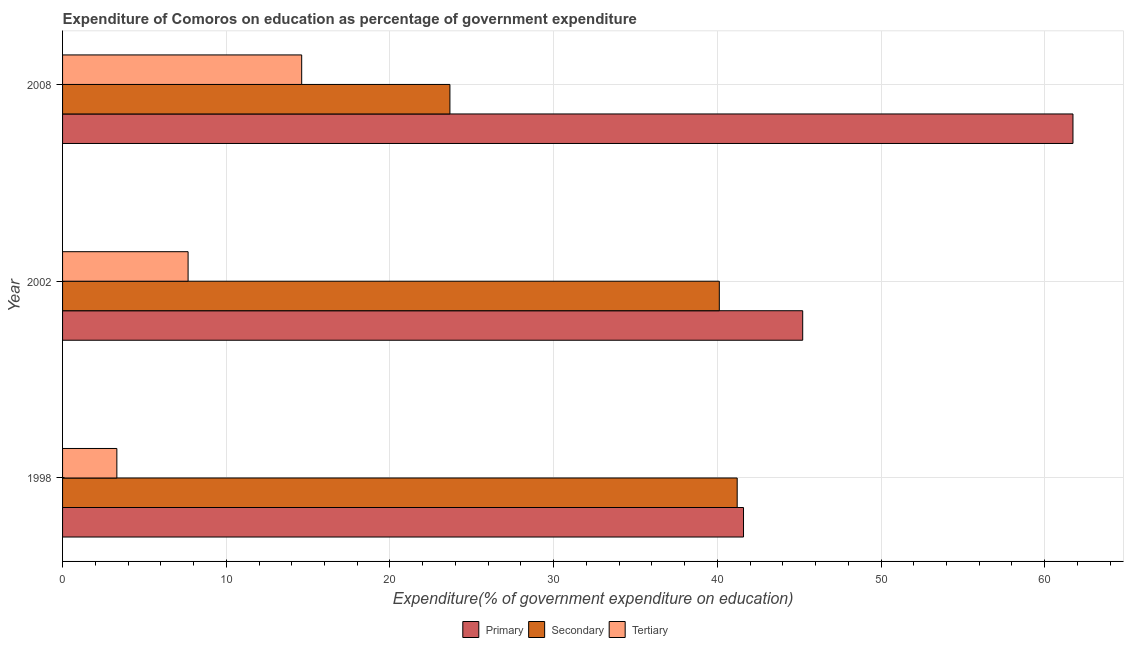Are the number of bars on each tick of the Y-axis equal?
Keep it short and to the point. Yes. How many bars are there on the 1st tick from the top?
Your answer should be compact. 3. What is the label of the 1st group of bars from the top?
Give a very brief answer. 2008. In how many cases, is the number of bars for a given year not equal to the number of legend labels?
Ensure brevity in your answer.  0. What is the expenditure on tertiary education in 2008?
Provide a short and direct response. 14.61. Across all years, what is the maximum expenditure on secondary education?
Provide a short and direct response. 41.21. Across all years, what is the minimum expenditure on tertiary education?
Your response must be concise. 3.32. What is the total expenditure on primary education in the graph?
Your answer should be very brief. 148.54. What is the difference between the expenditure on tertiary education in 2002 and that in 2008?
Offer a terse response. -6.94. What is the difference between the expenditure on tertiary education in 2008 and the expenditure on secondary education in 2002?
Keep it short and to the point. -25.51. What is the average expenditure on primary education per year?
Your response must be concise. 49.51. In the year 1998, what is the difference between the expenditure on secondary education and expenditure on tertiary education?
Give a very brief answer. 37.9. In how many years, is the expenditure on primary education greater than 8 %?
Offer a very short reply. 3. What is the ratio of the expenditure on secondary education in 1998 to that in 2002?
Make the answer very short. 1.03. What is the difference between the highest and the second highest expenditure on tertiary education?
Your response must be concise. 6.94. What is the difference between the highest and the lowest expenditure on secondary education?
Offer a terse response. 17.55. Is the sum of the expenditure on primary education in 2002 and 2008 greater than the maximum expenditure on tertiary education across all years?
Your answer should be very brief. Yes. What does the 3rd bar from the top in 1998 represents?
Your answer should be compact. Primary. What does the 3rd bar from the bottom in 1998 represents?
Make the answer very short. Tertiary. Is it the case that in every year, the sum of the expenditure on primary education and expenditure on secondary education is greater than the expenditure on tertiary education?
Make the answer very short. Yes. How many bars are there?
Make the answer very short. 9. Are all the bars in the graph horizontal?
Provide a succinct answer. Yes. Are the values on the major ticks of X-axis written in scientific E-notation?
Offer a terse response. No. How many legend labels are there?
Ensure brevity in your answer.  3. How are the legend labels stacked?
Keep it short and to the point. Horizontal. What is the title of the graph?
Offer a very short reply. Expenditure of Comoros on education as percentage of government expenditure. Does "Refusal of sex" appear as one of the legend labels in the graph?
Provide a succinct answer. No. What is the label or title of the X-axis?
Provide a succinct answer. Expenditure(% of government expenditure on education). What is the Expenditure(% of government expenditure on education) of Primary in 1998?
Provide a succinct answer. 41.6. What is the Expenditure(% of government expenditure on education) of Secondary in 1998?
Your answer should be very brief. 41.21. What is the Expenditure(% of government expenditure on education) in Tertiary in 1998?
Your answer should be compact. 3.32. What is the Expenditure(% of government expenditure on education) in Primary in 2002?
Keep it short and to the point. 45.21. What is the Expenditure(% of government expenditure on education) of Secondary in 2002?
Your answer should be very brief. 40.12. What is the Expenditure(% of government expenditure on education) of Tertiary in 2002?
Give a very brief answer. 7.67. What is the Expenditure(% of government expenditure on education) in Primary in 2008?
Offer a very short reply. 61.73. What is the Expenditure(% of government expenditure on education) of Secondary in 2008?
Give a very brief answer. 23.66. What is the Expenditure(% of government expenditure on education) in Tertiary in 2008?
Give a very brief answer. 14.61. Across all years, what is the maximum Expenditure(% of government expenditure on education) of Primary?
Your answer should be compact. 61.73. Across all years, what is the maximum Expenditure(% of government expenditure on education) in Secondary?
Make the answer very short. 41.21. Across all years, what is the maximum Expenditure(% of government expenditure on education) of Tertiary?
Offer a terse response. 14.61. Across all years, what is the minimum Expenditure(% of government expenditure on education) of Primary?
Make the answer very short. 41.6. Across all years, what is the minimum Expenditure(% of government expenditure on education) of Secondary?
Keep it short and to the point. 23.66. Across all years, what is the minimum Expenditure(% of government expenditure on education) of Tertiary?
Keep it short and to the point. 3.32. What is the total Expenditure(% of government expenditure on education) of Primary in the graph?
Your answer should be very brief. 148.54. What is the total Expenditure(% of government expenditure on education) of Secondary in the graph?
Offer a very short reply. 105. What is the total Expenditure(% of government expenditure on education) of Tertiary in the graph?
Keep it short and to the point. 25.59. What is the difference between the Expenditure(% of government expenditure on education) of Primary in 1998 and that in 2002?
Give a very brief answer. -3.62. What is the difference between the Expenditure(% of government expenditure on education) of Secondary in 1998 and that in 2002?
Offer a terse response. 1.09. What is the difference between the Expenditure(% of government expenditure on education) in Tertiary in 1998 and that in 2002?
Make the answer very short. -4.35. What is the difference between the Expenditure(% of government expenditure on education) of Primary in 1998 and that in 2008?
Give a very brief answer. -20.13. What is the difference between the Expenditure(% of government expenditure on education) in Secondary in 1998 and that in 2008?
Offer a terse response. 17.55. What is the difference between the Expenditure(% of government expenditure on education) of Tertiary in 1998 and that in 2008?
Offer a terse response. -11.29. What is the difference between the Expenditure(% of government expenditure on education) in Primary in 2002 and that in 2008?
Give a very brief answer. -16.51. What is the difference between the Expenditure(% of government expenditure on education) in Secondary in 2002 and that in 2008?
Your answer should be very brief. 16.46. What is the difference between the Expenditure(% of government expenditure on education) of Tertiary in 2002 and that in 2008?
Ensure brevity in your answer.  -6.94. What is the difference between the Expenditure(% of government expenditure on education) of Primary in 1998 and the Expenditure(% of government expenditure on education) of Secondary in 2002?
Provide a short and direct response. 1.48. What is the difference between the Expenditure(% of government expenditure on education) of Primary in 1998 and the Expenditure(% of government expenditure on education) of Tertiary in 2002?
Offer a very short reply. 33.93. What is the difference between the Expenditure(% of government expenditure on education) in Secondary in 1998 and the Expenditure(% of government expenditure on education) in Tertiary in 2002?
Make the answer very short. 33.54. What is the difference between the Expenditure(% of government expenditure on education) of Primary in 1998 and the Expenditure(% of government expenditure on education) of Secondary in 2008?
Your response must be concise. 17.94. What is the difference between the Expenditure(% of government expenditure on education) in Primary in 1998 and the Expenditure(% of government expenditure on education) in Tertiary in 2008?
Offer a terse response. 26.99. What is the difference between the Expenditure(% of government expenditure on education) of Secondary in 1998 and the Expenditure(% of government expenditure on education) of Tertiary in 2008?
Offer a very short reply. 26.61. What is the difference between the Expenditure(% of government expenditure on education) in Primary in 2002 and the Expenditure(% of government expenditure on education) in Secondary in 2008?
Offer a terse response. 21.55. What is the difference between the Expenditure(% of government expenditure on education) in Primary in 2002 and the Expenditure(% of government expenditure on education) in Tertiary in 2008?
Make the answer very short. 30.61. What is the difference between the Expenditure(% of government expenditure on education) in Secondary in 2002 and the Expenditure(% of government expenditure on education) in Tertiary in 2008?
Offer a terse response. 25.51. What is the average Expenditure(% of government expenditure on education) of Primary per year?
Your answer should be very brief. 49.51. What is the average Expenditure(% of government expenditure on education) of Secondary per year?
Ensure brevity in your answer.  35. What is the average Expenditure(% of government expenditure on education) of Tertiary per year?
Keep it short and to the point. 8.53. In the year 1998, what is the difference between the Expenditure(% of government expenditure on education) of Primary and Expenditure(% of government expenditure on education) of Secondary?
Offer a very short reply. 0.39. In the year 1998, what is the difference between the Expenditure(% of government expenditure on education) of Primary and Expenditure(% of government expenditure on education) of Tertiary?
Keep it short and to the point. 38.28. In the year 1998, what is the difference between the Expenditure(% of government expenditure on education) in Secondary and Expenditure(% of government expenditure on education) in Tertiary?
Make the answer very short. 37.9. In the year 2002, what is the difference between the Expenditure(% of government expenditure on education) of Primary and Expenditure(% of government expenditure on education) of Secondary?
Your answer should be compact. 5.09. In the year 2002, what is the difference between the Expenditure(% of government expenditure on education) of Primary and Expenditure(% of government expenditure on education) of Tertiary?
Ensure brevity in your answer.  37.55. In the year 2002, what is the difference between the Expenditure(% of government expenditure on education) of Secondary and Expenditure(% of government expenditure on education) of Tertiary?
Your answer should be compact. 32.45. In the year 2008, what is the difference between the Expenditure(% of government expenditure on education) in Primary and Expenditure(% of government expenditure on education) in Secondary?
Give a very brief answer. 38.06. In the year 2008, what is the difference between the Expenditure(% of government expenditure on education) of Primary and Expenditure(% of government expenditure on education) of Tertiary?
Provide a succinct answer. 47.12. In the year 2008, what is the difference between the Expenditure(% of government expenditure on education) of Secondary and Expenditure(% of government expenditure on education) of Tertiary?
Give a very brief answer. 9.06. What is the ratio of the Expenditure(% of government expenditure on education) in Secondary in 1998 to that in 2002?
Your response must be concise. 1.03. What is the ratio of the Expenditure(% of government expenditure on education) of Tertiary in 1998 to that in 2002?
Keep it short and to the point. 0.43. What is the ratio of the Expenditure(% of government expenditure on education) in Primary in 1998 to that in 2008?
Offer a terse response. 0.67. What is the ratio of the Expenditure(% of government expenditure on education) in Secondary in 1998 to that in 2008?
Keep it short and to the point. 1.74. What is the ratio of the Expenditure(% of government expenditure on education) of Tertiary in 1998 to that in 2008?
Ensure brevity in your answer.  0.23. What is the ratio of the Expenditure(% of government expenditure on education) of Primary in 2002 to that in 2008?
Provide a succinct answer. 0.73. What is the ratio of the Expenditure(% of government expenditure on education) of Secondary in 2002 to that in 2008?
Provide a succinct answer. 1.7. What is the ratio of the Expenditure(% of government expenditure on education) in Tertiary in 2002 to that in 2008?
Give a very brief answer. 0.53. What is the difference between the highest and the second highest Expenditure(% of government expenditure on education) in Primary?
Provide a succinct answer. 16.51. What is the difference between the highest and the second highest Expenditure(% of government expenditure on education) in Secondary?
Your answer should be very brief. 1.09. What is the difference between the highest and the second highest Expenditure(% of government expenditure on education) in Tertiary?
Your answer should be compact. 6.94. What is the difference between the highest and the lowest Expenditure(% of government expenditure on education) of Primary?
Provide a succinct answer. 20.13. What is the difference between the highest and the lowest Expenditure(% of government expenditure on education) of Secondary?
Your response must be concise. 17.55. What is the difference between the highest and the lowest Expenditure(% of government expenditure on education) of Tertiary?
Your response must be concise. 11.29. 